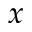Convert formula to latex. <formula><loc_0><loc_0><loc_500><loc_500>x</formula> 